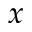Convert formula to latex. <formula><loc_0><loc_0><loc_500><loc_500>x</formula> 